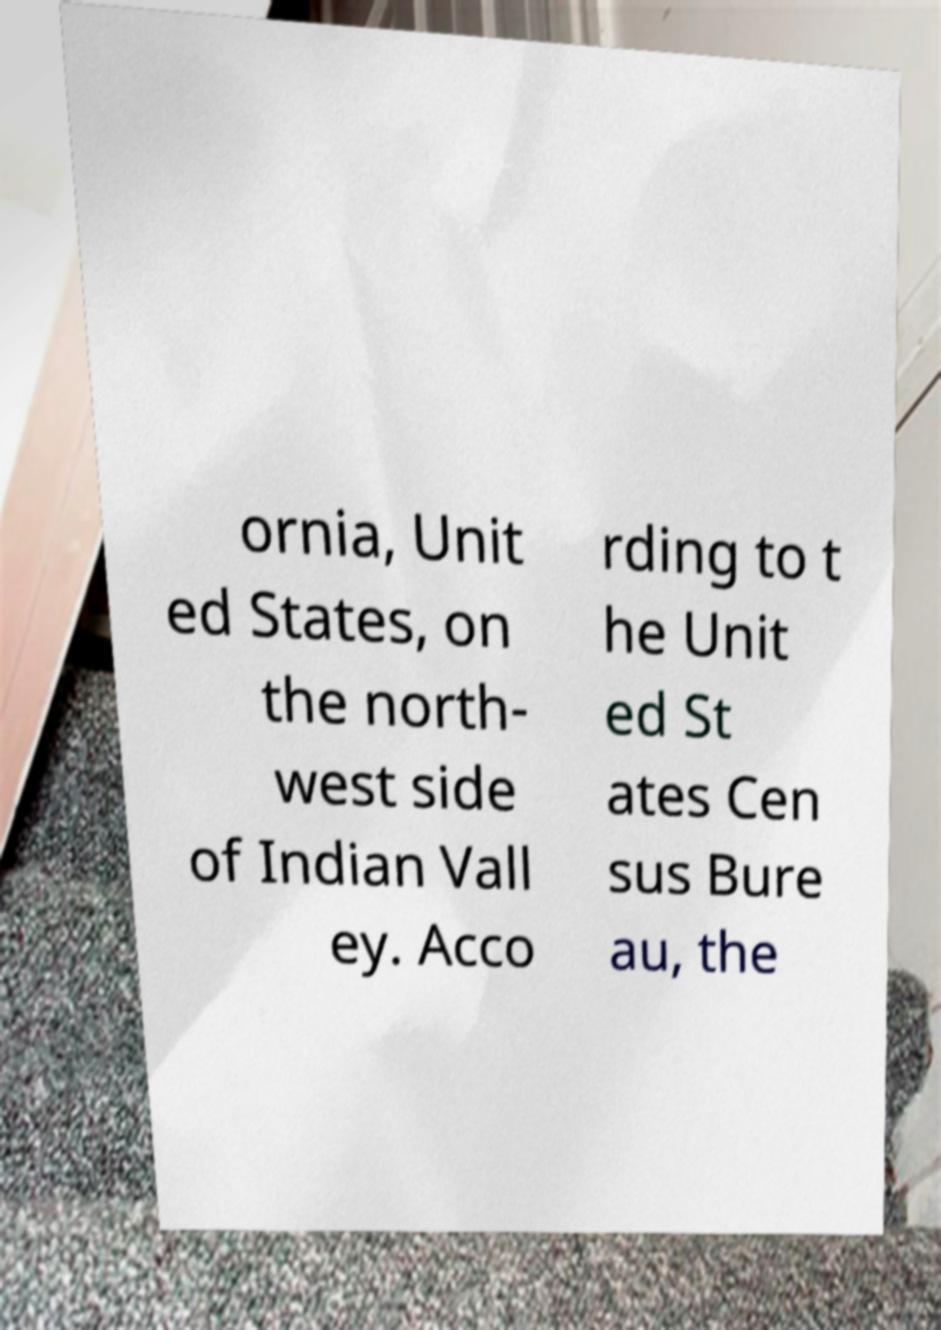What messages or text are displayed in this image? I need them in a readable, typed format. ornia, Unit ed States, on the north- west side of Indian Vall ey. Acco rding to t he Unit ed St ates Cen sus Bure au, the 